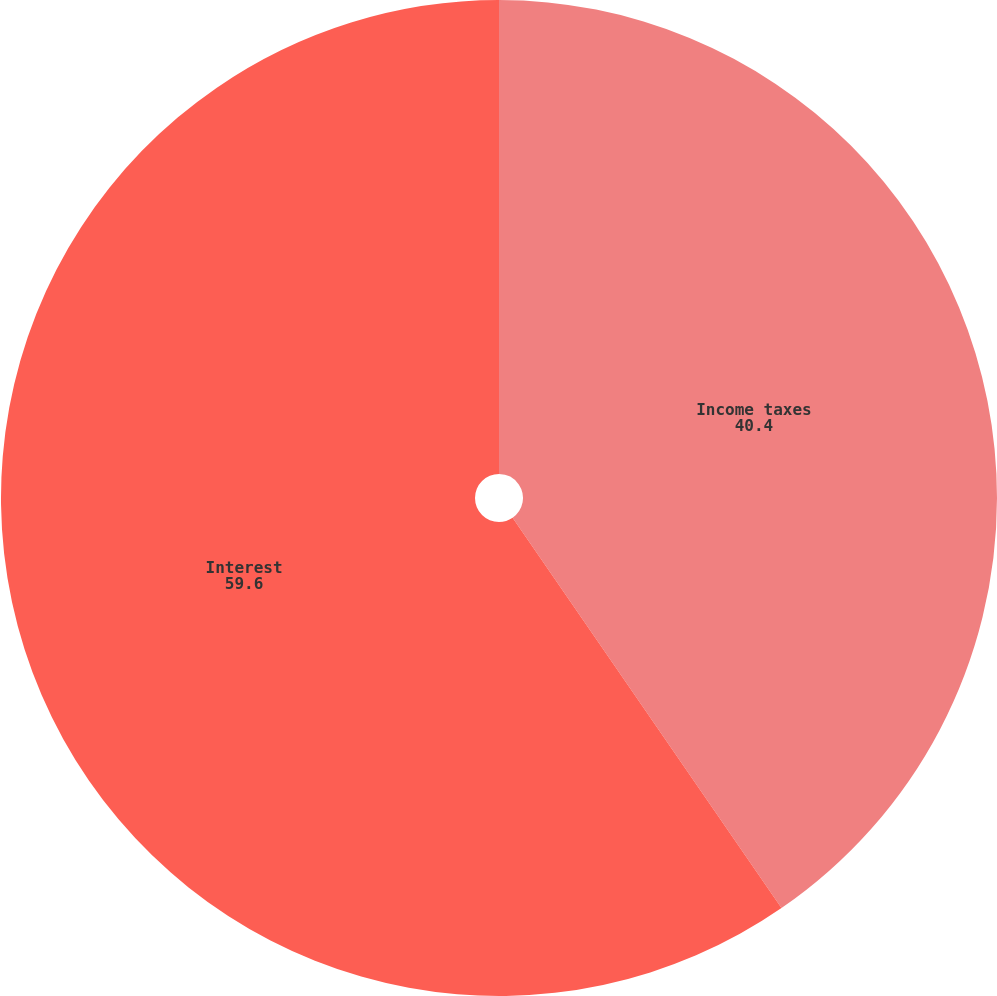Convert chart. <chart><loc_0><loc_0><loc_500><loc_500><pie_chart><fcel>Income taxes<fcel>Interest<nl><fcel>40.4%<fcel>59.6%<nl></chart> 